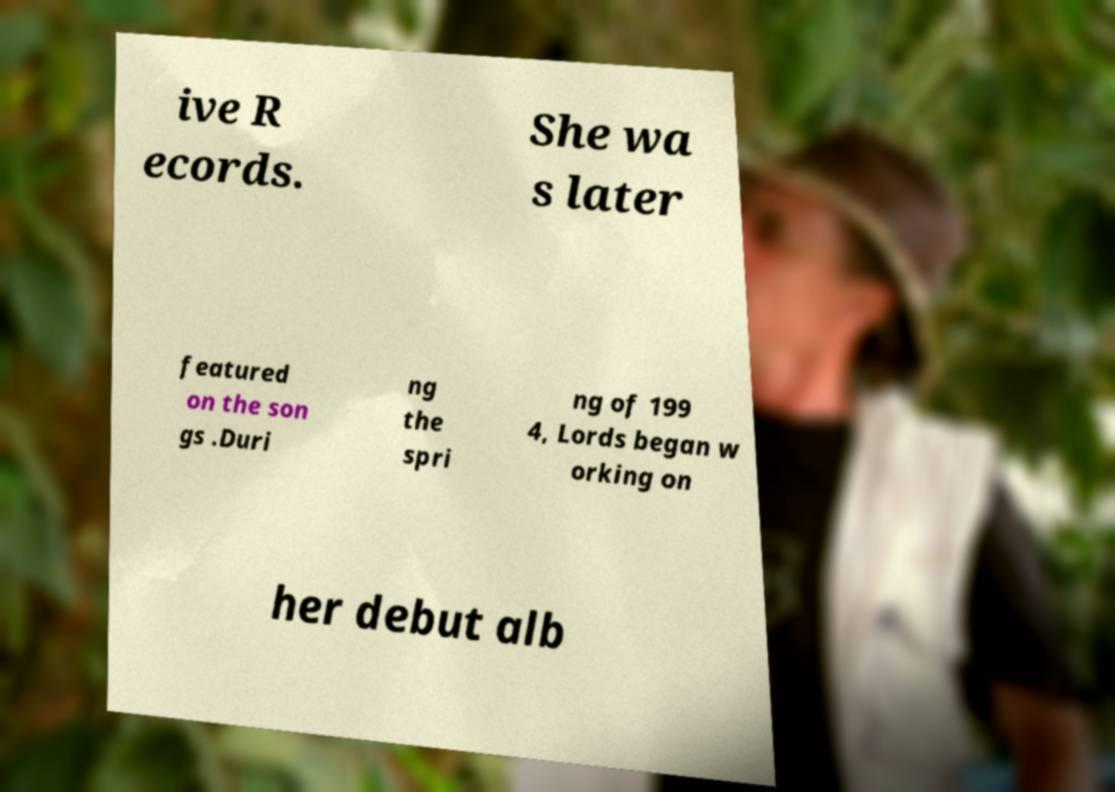Could you assist in decoding the text presented in this image and type it out clearly? ive R ecords. She wa s later featured on the son gs .Duri ng the spri ng of 199 4, Lords began w orking on her debut alb 